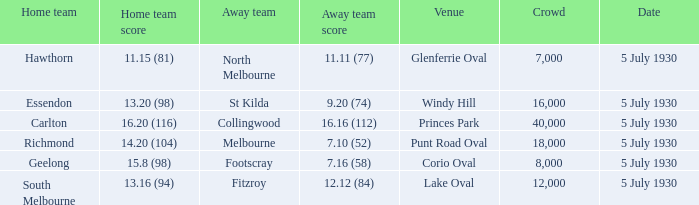Which team is the away side at corio oval? Footscray. 